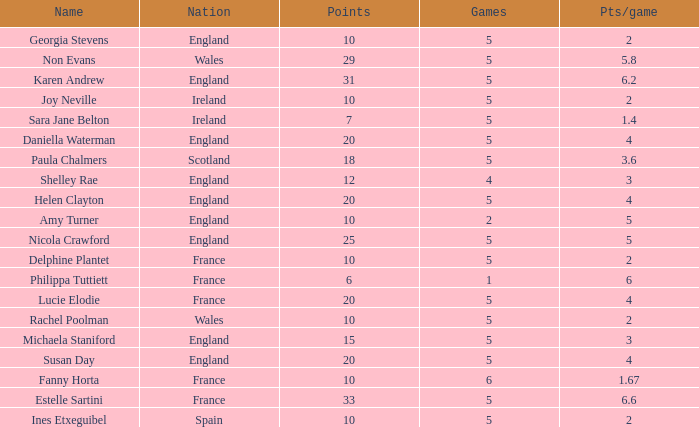Can you tell me the lowest Games that has the Pts/game larger than 1.4 and the Points of 20, and the Name of susan day? 5.0. 